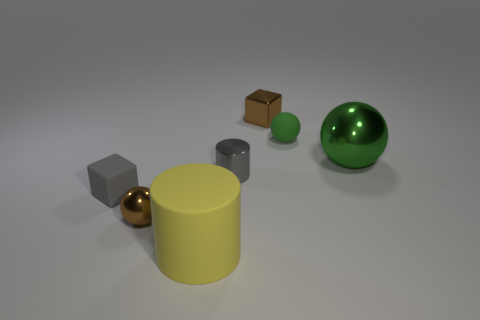Are there fewer small brown shiny spheres that are behind the small brown ball than small gray cubes that are behind the small rubber sphere?
Your answer should be compact. No. There is a cylinder that is behind the big object that is in front of the small gray block; is there a gray rubber object that is behind it?
Provide a succinct answer. No. What material is the tiny ball that is the same color as the metallic cube?
Offer a very short reply. Metal. There is a brown thing that is behind the brown metallic ball; is its shape the same as the big object left of the big metal thing?
Your response must be concise. No. What material is the green ball that is the same size as the matte cylinder?
Your response must be concise. Metal. Is the gray thing that is to the right of the gray cube made of the same material as the small sphere behind the green metallic sphere?
Provide a short and direct response. No. The gray metal thing that is the same size as the gray matte thing is what shape?
Ensure brevity in your answer.  Cylinder. How many other objects are there of the same color as the small metal cube?
Your answer should be very brief. 1. What is the color of the big thing that is right of the large yellow rubber cylinder?
Provide a short and direct response. Green. How many other objects are there of the same material as the gray cube?
Offer a terse response. 2. 